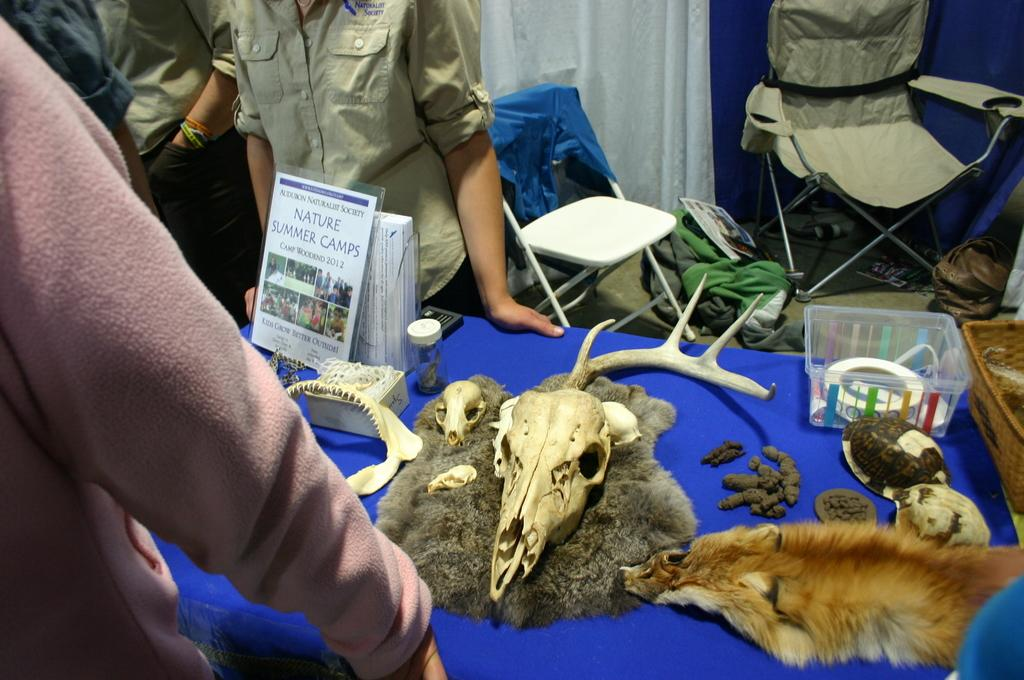What objects are on the table in the image? There are skulls on the table in the image. What can be seen in the background of the image? There are people standing and chairs in the background of the image. What type of corn is being harvested in the image? There is no corn present in the image; it features skulls on a table with people and chairs in the background. 